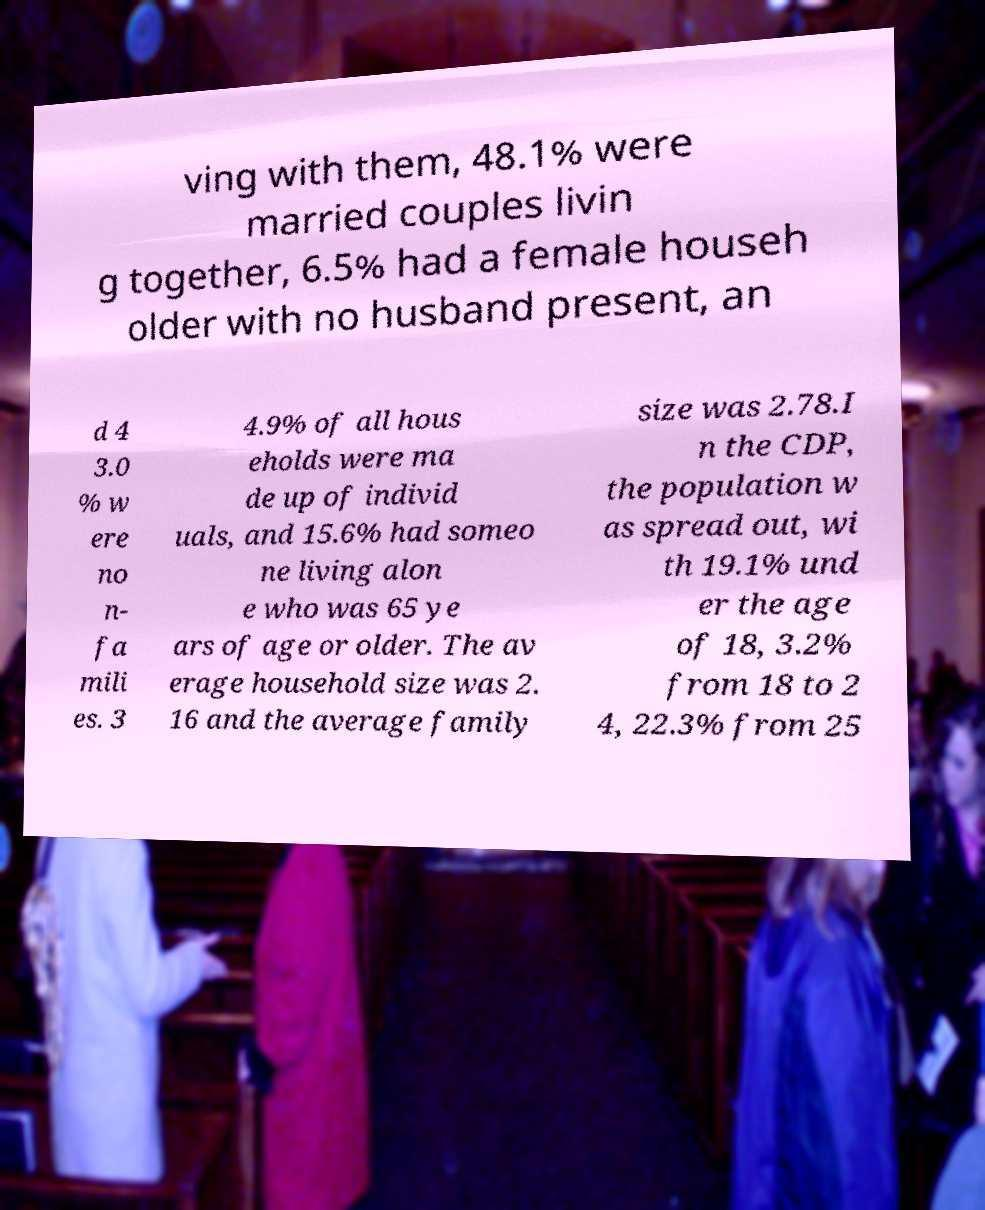Can you read and provide the text displayed in the image?This photo seems to have some interesting text. Can you extract and type it out for me? ving with them, 48.1% were married couples livin g together, 6.5% had a female househ older with no husband present, an d 4 3.0 % w ere no n- fa mili es. 3 4.9% of all hous eholds were ma de up of individ uals, and 15.6% had someo ne living alon e who was 65 ye ars of age or older. The av erage household size was 2. 16 and the average family size was 2.78.I n the CDP, the population w as spread out, wi th 19.1% und er the age of 18, 3.2% from 18 to 2 4, 22.3% from 25 